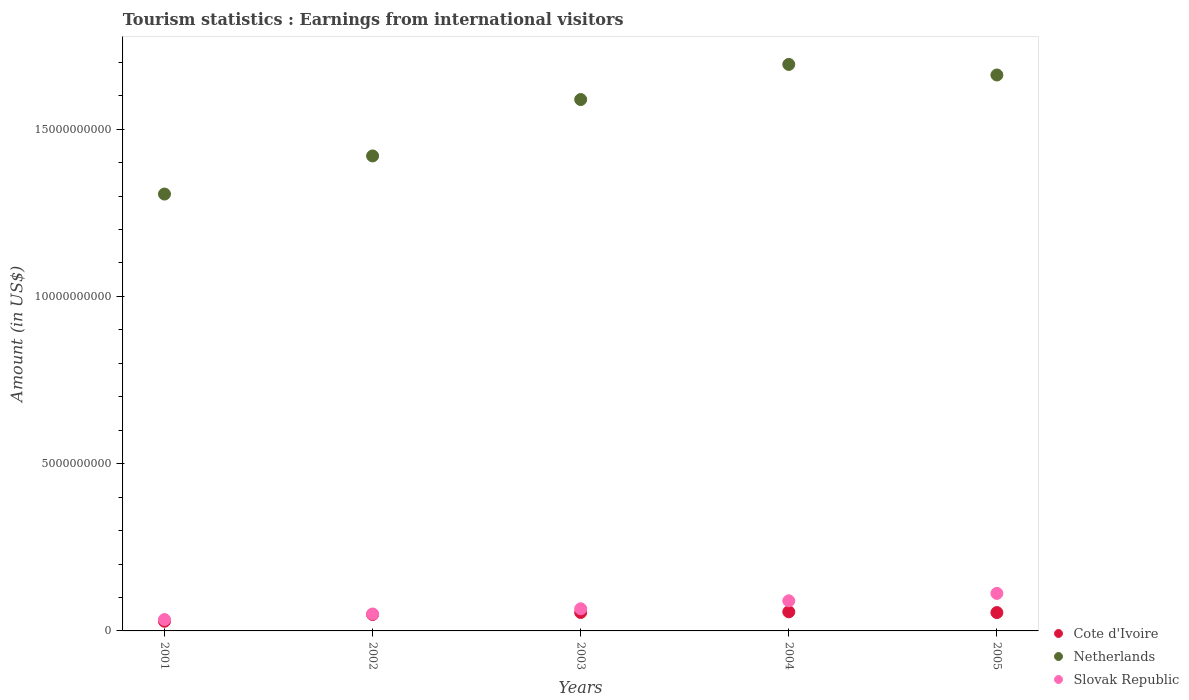What is the earnings from international visitors in Cote d'Ivoire in 2001?
Provide a short and direct response. 2.89e+08. Across all years, what is the maximum earnings from international visitors in Netherlands?
Give a very brief answer. 1.69e+1. Across all years, what is the minimum earnings from international visitors in Netherlands?
Your response must be concise. 1.31e+1. In which year was the earnings from international visitors in Cote d'Ivoire maximum?
Ensure brevity in your answer.  2004. In which year was the earnings from international visitors in Slovak Republic minimum?
Keep it short and to the point. 2001. What is the total earnings from international visitors in Slovak Republic in the graph?
Provide a succinct answer. 3.53e+09. What is the difference between the earnings from international visitors in Cote d'Ivoire in 2001 and that in 2004?
Your answer should be very brief. -2.82e+08. What is the difference between the earnings from international visitors in Slovak Republic in 2004 and the earnings from international visitors in Netherlands in 2002?
Your answer should be compact. -1.33e+1. What is the average earnings from international visitors in Cote d'Ivoire per year?
Offer a very short reply. 4.90e+08. In the year 2003, what is the difference between the earnings from international visitors in Slovak Republic and earnings from international visitors in Netherlands?
Offer a terse response. -1.52e+1. In how many years, is the earnings from international visitors in Netherlands greater than 15000000000 US$?
Your answer should be compact. 3. What is the ratio of the earnings from international visitors in Netherlands in 2001 to that in 2005?
Your response must be concise. 0.79. Is the difference between the earnings from international visitors in Slovak Republic in 2002 and 2003 greater than the difference between the earnings from international visitors in Netherlands in 2002 and 2003?
Ensure brevity in your answer.  Yes. What is the difference between the highest and the second highest earnings from international visitors in Slovak Republic?
Your answer should be compact. 2.22e+08. What is the difference between the highest and the lowest earnings from international visitors in Cote d'Ivoire?
Ensure brevity in your answer.  2.82e+08. Is it the case that in every year, the sum of the earnings from international visitors in Slovak Republic and earnings from international visitors in Netherlands  is greater than the earnings from international visitors in Cote d'Ivoire?
Your answer should be compact. Yes. Are the values on the major ticks of Y-axis written in scientific E-notation?
Your answer should be compact. No. Where does the legend appear in the graph?
Give a very brief answer. Bottom right. What is the title of the graph?
Give a very brief answer. Tourism statistics : Earnings from international visitors. Does "Costa Rica" appear as one of the legend labels in the graph?
Give a very brief answer. No. What is the label or title of the X-axis?
Keep it short and to the point. Years. What is the label or title of the Y-axis?
Your answer should be very brief. Amount (in US$). What is the Amount (in US$) of Cote d'Ivoire in 2001?
Your response must be concise. 2.89e+08. What is the Amount (in US$) in Netherlands in 2001?
Your answer should be very brief. 1.31e+1. What is the Amount (in US$) of Slovak Republic in 2001?
Your answer should be compact. 3.40e+08. What is the Amount (in US$) in Cote d'Ivoire in 2002?
Your answer should be very brief. 4.90e+08. What is the Amount (in US$) of Netherlands in 2002?
Keep it short and to the point. 1.42e+1. What is the Amount (in US$) in Slovak Republic in 2002?
Provide a short and direct response. 5.06e+08. What is the Amount (in US$) of Cote d'Ivoire in 2003?
Provide a short and direct response. 5.51e+08. What is the Amount (in US$) in Netherlands in 2003?
Make the answer very short. 1.59e+1. What is the Amount (in US$) of Slovak Republic in 2003?
Your answer should be compact. 6.62e+08. What is the Amount (in US$) of Cote d'Ivoire in 2004?
Your answer should be compact. 5.71e+08. What is the Amount (in US$) of Netherlands in 2004?
Offer a terse response. 1.69e+1. What is the Amount (in US$) in Slovak Republic in 2004?
Provide a succinct answer. 9.00e+08. What is the Amount (in US$) of Cote d'Ivoire in 2005?
Make the answer very short. 5.49e+08. What is the Amount (in US$) of Netherlands in 2005?
Make the answer very short. 1.66e+1. What is the Amount (in US$) in Slovak Republic in 2005?
Provide a short and direct response. 1.12e+09. Across all years, what is the maximum Amount (in US$) of Cote d'Ivoire?
Provide a short and direct response. 5.71e+08. Across all years, what is the maximum Amount (in US$) in Netherlands?
Your answer should be very brief. 1.69e+1. Across all years, what is the maximum Amount (in US$) of Slovak Republic?
Give a very brief answer. 1.12e+09. Across all years, what is the minimum Amount (in US$) in Cote d'Ivoire?
Offer a terse response. 2.89e+08. Across all years, what is the minimum Amount (in US$) of Netherlands?
Provide a short and direct response. 1.31e+1. Across all years, what is the minimum Amount (in US$) in Slovak Republic?
Keep it short and to the point. 3.40e+08. What is the total Amount (in US$) of Cote d'Ivoire in the graph?
Your answer should be compact. 2.45e+09. What is the total Amount (in US$) in Netherlands in the graph?
Your answer should be very brief. 7.67e+1. What is the total Amount (in US$) of Slovak Republic in the graph?
Offer a terse response. 3.53e+09. What is the difference between the Amount (in US$) in Cote d'Ivoire in 2001 and that in 2002?
Provide a short and direct response. -2.01e+08. What is the difference between the Amount (in US$) in Netherlands in 2001 and that in 2002?
Keep it short and to the point. -1.14e+09. What is the difference between the Amount (in US$) of Slovak Republic in 2001 and that in 2002?
Your answer should be compact. -1.66e+08. What is the difference between the Amount (in US$) of Cote d'Ivoire in 2001 and that in 2003?
Provide a short and direct response. -2.62e+08. What is the difference between the Amount (in US$) in Netherlands in 2001 and that in 2003?
Keep it short and to the point. -2.83e+09. What is the difference between the Amount (in US$) of Slovak Republic in 2001 and that in 2003?
Give a very brief answer. -3.22e+08. What is the difference between the Amount (in US$) in Cote d'Ivoire in 2001 and that in 2004?
Your answer should be very brief. -2.82e+08. What is the difference between the Amount (in US$) of Netherlands in 2001 and that in 2004?
Ensure brevity in your answer.  -3.88e+09. What is the difference between the Amount (in US$) in Slovak Republic in 2001 and that in 2004?
Your answer should be very brief. -5.60e+08. What is the difference between the Amount (in US$) of Cote d'Ivoire in 2001 and that in 2005?
Your response must be concise. -2.60e+08. What is the difference between the Amount (in US$) of Netherlands in 2001 and that in 2005?
Offer a terse response. -3.56e+09. What is the difference between the Amount (in US$) of Slovak Republic in 2001 and that in 2005?
Provide a succinct answer. -7.82e+08. What is the difference between the Amount (in US$) in Cote d'Ivoire in 2002 and that in 2003?
Your answer should be very brief. -6.10e+07. What is the difference between the Amount (in US$) in Netherlands in 2002 and that in 2003?
Give a very brief answer. -1.69e+09. What is the difference between the Amount (in US$) in Slovak Republic in 2002 and that in 2003?
Provide a succinct answer. -1.56e+08. What is the difference between the Amount (in US$) in Cote d'Ivoire in 2002 and that in 2004?
Provide a short and direct response. -8.10e+07. What is the difference between the Amount (in US$) in Netherlands in 2002 and that in 2004?
Keep it short and to the point. -2.74e+09. What is the difference between the Amount (in US$) of Slovak Republic in 2002 and that in 2004?
Provide a short and direct response. -3.94e+08. What is the difference between the Amount (in US$) in Cote d'Ivoire in 2002 and that in 2005?
Your answer should be very brief. -5.90e+07. What is the difference between the Amount (in US$) of Netherlands in 2002 and that in 2005?
Make the answer very short. -2.42e+09. What is the difference between the Amount (in US$) in Slovak Republic in 2002 and that in 2005?
Make the answer very short. -6.16e+08. What is the difference between the Amount (in US$) in Cote d'Ivoire in 2003 and that in 2004?
Your answer should be very brief. -2.00e+07. What is the difference between the Amount (in US$) in Netherlands in 2003 and that in 2004?
Your answer should be compact. -1.05e+09. What is the difference between the Amount (in US$) of Slovak Republic in 2003 and that in 2004?
Offer a terse response. -2.38e+08. What is the difference between the Amount (in US$) of Cote d'Ivoire in 2003 and that in 2005?
Give a very brief answer. 2.00e+06. What is the difference between the Amount (in US$) in Netherlands in 2003 and that in 2005?
Make the answer very short. -7.34e+08. What is the difference between the Amount (in US$) in Slovak Republic in 2003 and that in 2005?
Keep it short and to the point. -4.60e+08. What is the difference between the Amount (in US$) in Cote d'Ivoire in 2004 and that in 2005?
Ensure brevity in your answer.  2.20e+07. What is the difference between the Amount (in US$) of Netherlands in 2004 and that in 2005?
Give a very brief answer. 3.16e+08. What is the difference between the Amount (in US$) in Slovak Republic in 2004 and that in 2005?
Your response must be concise. -2.22e+08. What is the difference between the Amount (in US$) of Cote d'Ivoire in 2001 and the Amount (in US$) of Netherlands in 2002?
Offer a very short reply. -1.39e+1. What is the difference between the Amount (in US$) of Cote d'Ivoire in 2001 and the Amount (in US$) of Slovak Republic in 2002?
Your answer should be very brief. -2.17e+08. What is the difference between the Amount (in US$) in Netherlands in 2001 and the Amount (in US$) in Slovak Republic in 2002?
Ensure brevity in your answer.  1.26e+1. What is the difference between the Amount (in US$) of Cote d'Ivoire in 2001 and the Amount (in US$) of Netherlands in 2003?
Keep it short and to the point. -1.56e+1. What is the difference between the Amount (in US$) of Cote d'Ivoire in 2001 and the Amount (in US$) of Slovak Republic in 2003?
Your answer should be compact. -3.73e+08. What is the difference between the Amount (in US$) of Netherlands in 2001 and the Amount (in US$) of Slovak Republic in 2003?
Keep it short and to the point. 1.24e+1. What is the difference between the Amount (in US$) of Cote d'Ivoire in 2001 and the Amount (in US$) of Netherlands in 2004?
Provide a short and direct response. -1.66e+1. What is the difference between the Amount (in US$) in Cote d'Ivoire in 2001 and the Amount (in US$) in Slovak Republic in 2004?
Your response must be concise. -6.11e+08. What is the difference between the Amount (in US$) in Netherlands in 2001 and the Amount (in US$) in Slovak Republic in 2004?
Make the answer very short. 1.22e+1. What is the difference between the Amount (in US$) in Cote d'Ivoire in 2001 and the Amount (in US$) in Netherlands in 2005?
Give a very brief answer. -1.63e+1. What is the difference between the Amount (in US$) in Cote d'Ivoire in 2001 and the Amount (in US$) in Slovak Republic in 2005?
Your response must be concise. -8.33e+08. What is the difference between the Amount (in US$) in Netherlands in 2001 and the Amount (in US$) in Slovak Republic in 2005?
Your answer should be very brief. 1.19e+1. What is the difference between the Amount (in US$) in Cote d'Ivoire in 2002 and the Amount (in US$) in Netherlands in 2003?
Your response must be concise. -1.54e+1. What is the difference between the Amount (in US$) in Cote d'Ivoire in 2002 and the Amount (in US$) in Slovak Republic in 2003?
Your answer should be compact. -1.72e+08. What is the difference between the Amount (in US$) in Netherlands in 2002 and the Amount (in US$) in Slovak Republic in 2003?
Your answer should be very brief. 1.35e+1. What is the difference between the Amount (in US$) in Cote d'Ivoire in 2002 and the Amount (in US$) in Netherlands in 2004?
Offer a very short reply. -1.64e+1. What is the difference between the Amount (in US$) in Cote d'Ivoire in 2002 and the Amount (in US$) in Slovak Republic in 2004?
Provide a short and direct response. -4.10e+08. What is the difference between the Amount (in US$) of Netherlands in 2002 and the Amount (in US$) of Slovak Republic in 2004?
Offer a very short reply. 1.33e+1. What is the difference between the Amount (in US$) of Cote d'Ivoire in 2002 and the Amount (in US$) of Netherlands in 2005?
Give a very brief answer. -1.61e+1. What is the difference between the Amount (in US$) in Cote d'Ivoire in 2002 and the Amount (in US$) in Slovak Republic in 2005?
Ensure brevity in your answer.  -6.32e+08. What is the difference between the Amount (in US$) of Netherlands in 2002 and the Amount (in US$) of Slovak Republic in 2005?
Provide a short and direct response. 1.31e+1. What is the difference between the Amount (in US$) in Cote d'Ivoire in 2003 and the Amount (in US$) in Netherlands in 2004?
Make the answer very short. -1.64e+1. What is the difference between the Amount (in US$) in Cote d'Ivoire in 2003 and the Amount (in US$) in Slovak Republic in 2004?
Offer a very short reply. -3.49e+08. What is the difference between the Amount (in US$) of Netherlands in 2003 and the Amount (in US$) of Slovak Republic in 2004?
Offer a very short reply. 1.50e+1. What is the difference between the Amount (in US$) in Cote d'Ivoire in 2003 and the Amount (in US$) in Netherlands in 2005?
Provide a succinct answer. -1.61e+1. What is the difference between the Amount (in US$) in Cote d'Ivoire in 2003 and the Amount (in US$) in Slovak Republic in 2005?
Your answer should be very brief. -5.71e+08. What is the difference between the Amount (in US$) of Netherlands in 2003 and the Amount (in US$) of Slovak Republic in 2005?
Offer a terse response. 1.48e+1. What is the difference between the Amount (in US$) in Cote d'Ivoire in 2004 and the Amount (in US$) in Netherlands in 2005?
Your answer should be very brief. -1.60e+1. What is the difference between the Amount (in US$) of Cote d'Ivoire in 2004 and the Amount (in US$) of Slovak Republic in 2005?
Offer a terse response. -5.51e+08. What is the difference between the Amount (in US$) of Netherlands in 2004 and the Amount (in US$) of Slovak Republic in 2005?
Give a very brief answer. 1.58e+1. What is the average Amount (in US$) of Cote d'Ivoire per year?
Your response must be concise. 4.90e+08. What is the average Amount (in US$) in Netherlands per year?
Offer a terse response. 1.53e+1. What is the average Amount (in US$) of Slovak Republic per year?
Ensure brevity in your answer.  7.06e+08. In the year 2001, what is the difference between the Amount (in US$) of Cote d'Ivoire and Amount (in US$) of Netherlands?
Provide a short and direct response. -1.28e+1. In the year 2001, what is the difference between the Amount (in US$) of Cote d'Ivoire and Amount (in US$) of Slovak Republic?
Your answer should be compact. -5.10e+07. In the year 2001, what is the difference between the Amount (in US$) of Netherlands and Amount (in US$) of Slovak Republic?
Give a very brief answer. 1.27e+1. In the year 2002, what is the difference between the Amount (in US$) in Cote d'Ivoire and Amount (in US$) in Netherlands?
Offer a very short reply. -1.37e+1. In the year 2002, what is the difference between the Amount (in US$) of Cote d'Ivoire and Amount (in US$) of Slovak Republic?
Keep it short and to the point. -1.60e+07. In the year 2002, what is the difference between the Amount (in US$) of Netherlands and Amount (in US$) of Slovak Republic?
Your answer should be compact. 1.37e+1. In the year 2003, what is the difference between the Amount (in US$) of Cote d'Ivoire and Amount (in US$) of Netherlands?
Your response must be concise. -1.53e+1. In the year 2003, what is the difference between the Amount (in US$) in Cote d'Ivoire and Amount (in US$) in Slovak Republic?
Offer a terse response. -1.11e+08. In the year 2003, what is the difference between the Amount (in US$) of Netherlands and Amount (in US$) of Slovak Republic?
Provide a short and direct response. 1.52e+1. In the year 2004, what is the difference between the Amount (in US$) of Cote d'Ivoire and Amount (in US$) of Netherlands?
Give a very brief answer. -1.64e+1. In the year 2004, what is the difference between the Amount (in US$) of Cote d'Ivoire and Amount (in US$) of Slovak Republic?
Provide a succinct answer. -3.29e+08. In the year 2004, what is the difference between the Amount (in US$) of Netherlands and Amount (in US$) of Slovak Republic?
Make the answer very short. 1.60e+1. In the year 2005, what is the difference between the Amount (in US$) of Cote d'Ivoire and Amount (in US$) of Netherlands?
Provide a succinct answer. -1.61e+1. In the year 2005, what is the difference between the Amount (in US$) in Cote d'Ivoire and Amount (in US$) in Slovak Republic?
Provide a short and direct response. -5.73e+08. In the year 2005, what is the difference between the Amount (in US$) of Netherlands and Amount (in US$) of Slovak Republic?
Make the answer very short. 1.55e+1. What is the ratio of the Amount (in US$) of Cote d'Ivoire in 2001 to that in 2002?
Ensure brevity in your answer.  0.59. What is the ratio of the Amount (in US$) in Netherlands in 2001 to that in 2002?
Your answer should be compact. 0.92. What is the ratio of the Amount (in US$) of Slovak Republic in 2001 to that in 2002?
Your answer should be very brief. 0.67. What is the ratio of the Amount (in US$) in Cote d'Ivoire in 2001 to that in 2003?
Offer a terse response. 0.52. What is the ratio of the Amount (in US$) in Netherlands in 2001 to that in 2003?
Keep it short and to the point. 0.82. What is the ratio of the Amount (in US$) of Slovak Republic in 2001 to that in 2003?
Your answer should be compact. 0.51. What is the ratio of the Amount (in US$) of Cote d'Ivoire in 2001 to that in 2004?
Keep it short and to the point. 0.51. What is the ratio of the Amount (in US$) of Netherlands in 2001 to that in 2004?
Keep it short and to the point. 0.77. What is the ratio of the Amount (in US$) of Slovak Republic in 2001 to that in 2004?
Provide a short and direct response. 0.38. What is the ratio of the Amount (in US$) in Cote d'Ivoire in 2001 to that in 2005?
Provide a short and direct response. 0.53. What is the ratio of the Amount (in US$) of Netherlands in 2001 to that in 2005?
Give a very brief answer. 0.79. What is the ratio of the Amount (in US$) in Slovak Republic in 2001 to that in 2005?
Provide a succinct answer. 0.3. What is the ratio of the Amount (in US$) in Cote d'Ivoire in 2002 to that in 2003?
Make the answer very short. 0.89. What is the ratio of the Amount (in US$) in Netherlands in 2002 to that in 2003?
Make the answer very short. 0.89. What is the ratio of the Amount (in US$) of Slovak Republic in 2002 to that in 2003?
Your answer should be very brief. 0.76. What is the ratio of the Amount (in US$) of Cote d'Ivoire in 2002 to that in 2004?
Your response must be concise. 0.86. What is the ratio of the Amount (in US$) in Netherlands in 2002 to that in 2004?
Your answer should be compact. 0.84. What is the ratio of the Amount (in US$) of Slovak Republic in 2002 to that in 2004?
Your response must be concise. 0.56. What is the ratio of the Amount (in US$) in Cote d'Ivoire in 2002 to that in 2005?
Your answer should be compact. 0.89. What is the ratio of the Amount (in US$) of Netherlands in 2002 to that in 2005?
Keep it short and to the point. 0.85. What is the ratio of the Amount (in US$) in Slovak Republic in 2002 to that in 2005?
Provide a succinct answer. 0.45. What is the ratio of the Amount (in US$) in Netherlands in 2003 to that in 2004?
Keep it short and to the point. 0.94. What is the ratio of the Amount (in US$) of Slovak Republic in 2003 to that in 2004?
Your answer should be compact. 0.74. What is the ratio of the Amount (in US$) in Cote d'Ivoire in 2003 to that in 2005?
Give a very brief answer. 1. What is the ratio of the Amount (in US$) in Netherlands in 2003 to that in 2005?
Ensure brevity in your answer.  0.96. What is the ratio of the Amount (in US$) of Slovak Republic in 2003 to that in 2005?
Offer a very short reply. 0.59. What is the ratio of the Amount (in US$) in Cote d'Ivoire in 2004 to that in 2005?
Your response must be concise. 1.04. What is the ratio of the Amount (in US$) in Slovak Republic in 2004 to that in 2005?
Your response must be concise. 0.8. What is the difference between the highest and the second highest Amount (in US$) of Cote d'Ivoire?
Give a very brief answer. 2.00e+07. What is the difference between the highest and the second highest Amount (in US$) of Netherlands?
Provide a short and direct response. 3.16e+08. What is the difference between the highest and the second highest Amount (in US$) of Slovak Republic?
Offer a very short reply. 2.22e+08. What is the difference between the highest and the lowest Amount (in US$) in Cote d'Ivoire?
Offer a terse response. 2.82e+08. What is the difference between the highest and the lowest Amount (in US$) of Netherlands?
Your answer should be compact. 3.88e+09. What is the difference between the highest and the lowest Amount (in US$) of Slovak Republic?
Your answer should be very brief. 7.82e+08. 